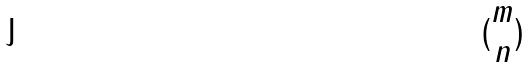Convert formula to latex. <formula><loc_0><loc_0><loc_500><loc_500>( \begin{matrix} m \\ n \end{matrix} )</formula> 